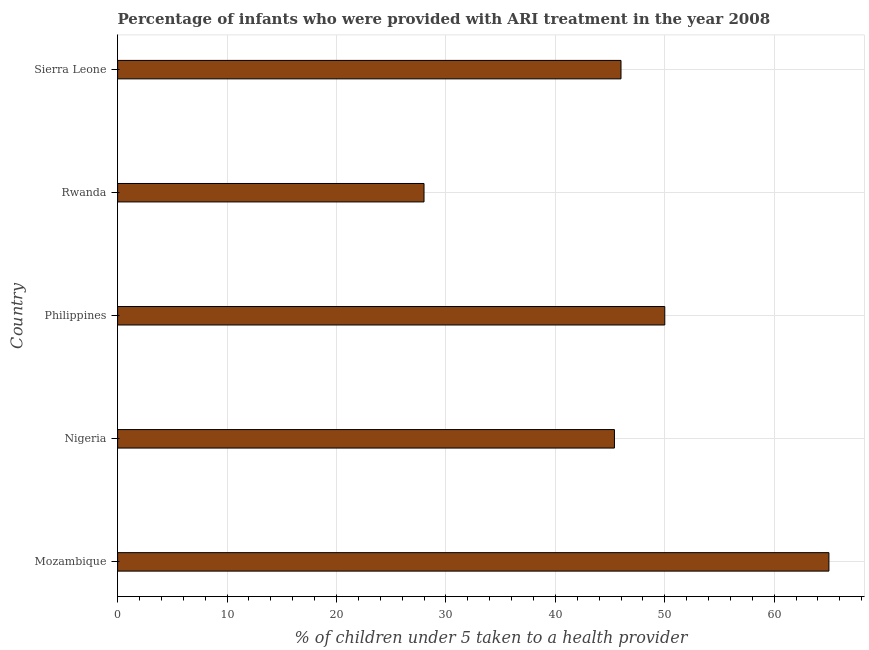What is the title of the graph?
Your answer should be very brief. Percentage of infants who were provided with ARI treatment in the year 2008. What is the label or title of the X-axis?
Offer a very short reply. % of children under 5 taken to a health provider. What is the label or title of the Y-axis?
Provide a short and direct response. Country. What is the percentage of children who were provided with ari treatment in Sierra Leone?
Offer a very short reply. 46. Across all countries, what is the minimum percentage of children who were provided with ari treatment?
Make the answer very short. 28. In which country was the percentage of children who were provided with ari treatment maximum?
Offer a very short reply. Mozambique. In which country was the percentage of children who were provided with ari treatment minimum?
Provide a short and direct response. Rwanda. What is the sum of the percentage of children who were provided with ari treatment?
Give a very brief answer. 234.4. What is the average percentage of children who were provided with ari treatment per country?
Offer a very short reply. 46.88. In how many countries, is the percentage of children who were provided with ari treatment greater than 22 %?
Make the answer very short. 5. What is the ratio of the percentage of children who were provided with ari treatment in Philippines to that in Sierra Leone?
Offer a very short reply. 1.09. Is the difference between the percentage of children who were provided with ari treatment in Nigeria and Philippines greater than the difference between any two countries?
Offer a terse response. No. Is the sum of the percentage of children who were provided with ari treatment in Rwanda and Sierra Leone greater than the maximum percentage of children who were provided with ari treatment across all countries?
Provide a succinct answer. Yes. What is the difference between the highest and the lowest percentage of children who were provided with ari treatment?
Your answer should be very brief. 37. How many bars are there?
Keep it short and to the point. 5. What is the difference between two consecutive major ticks on the X-axis?
Keep it short and to the point. 10. Are the values on the major ticks of X-axis written in scientific E-notation?
Offer a very short reply. No. What is the % of children under 5 taken to a health provider in Nigeria?
Give a very brief answer. 45.4. What is the % of children under 5 taken to a health provider in Rwanda?
Make the answer very short. 28. What is the difference between the % of children under 5 taken to a health provider in Mozambique and Nigeria?
Your answer should be very brief. 19.6. What is the difference between the % of children under 5 taken to a health provider in Mozambique and Sierra Leone?
Offer a very short reply. 19. What is the difference between the % of children under 5 taken to a health provider in Philippines and Rwanda?
Your answer should be compact. 22. What is the difference between the % of children under 5 taken to a health provider in Rwanda and Sierra Leone?
Offer a very short reply. -18. What is the ratio of the % of children under 5 taken to a health provider in Mozambique to that in Nigeria?
Offer a very short reply. 1.43. What is the ratio of the % of children under 5 taken to a health provider in Mozambique to that in Philippines?
Make the answer very short. 1.3. What is the ratio of the % of children under 5 taken to a health provider in Mozambique to that in Rwanda?
Your response must be concise. 2.32. What is the ratio of the % of children under 5 taken to a health provider in Mozambique to that in Sierra Leone?
Your answer should be very brief. 1.41. What is the ratio of the % of children under 5 taken to a health provider in Nigeria to that in Philippines?
Provide a short and direct response. 0.91. What is the ratio of the % of children under 5 taken to a health provider in Nigeria to that in Rwanda?
Ensure brevity in your answer.  1.62. What is the ratio of the % of children under 5 taken to a health provider in Philippines to that in Rwanda?
Your answer should be compact. 1.79. What is the ratio of the % of children under 5 taken to a health provider in Philippines to that in Sierra Leone?
Offer a very short reply. 1.09. What is the ratio of the % of children under 5 taken to a health provider in Rwanda to that in Sierra Leone?
Make the answer very short. 0.61. 